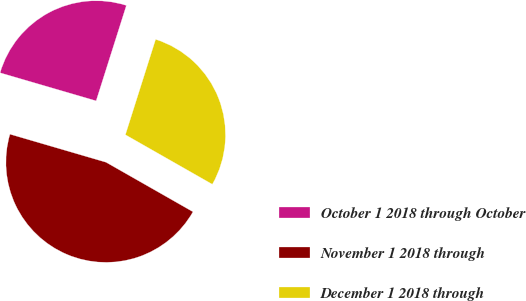Convert chart. <chart><loc_0><loc_0><loc_500><loc_500><pie_chart><fcel>October 1 2018 through October<fcel>November 1 2018 through<fcel>December 1 2018 through<nl><fcel>25.36%<fcel>46.28%<fcel>28.36%<nl></chart> 